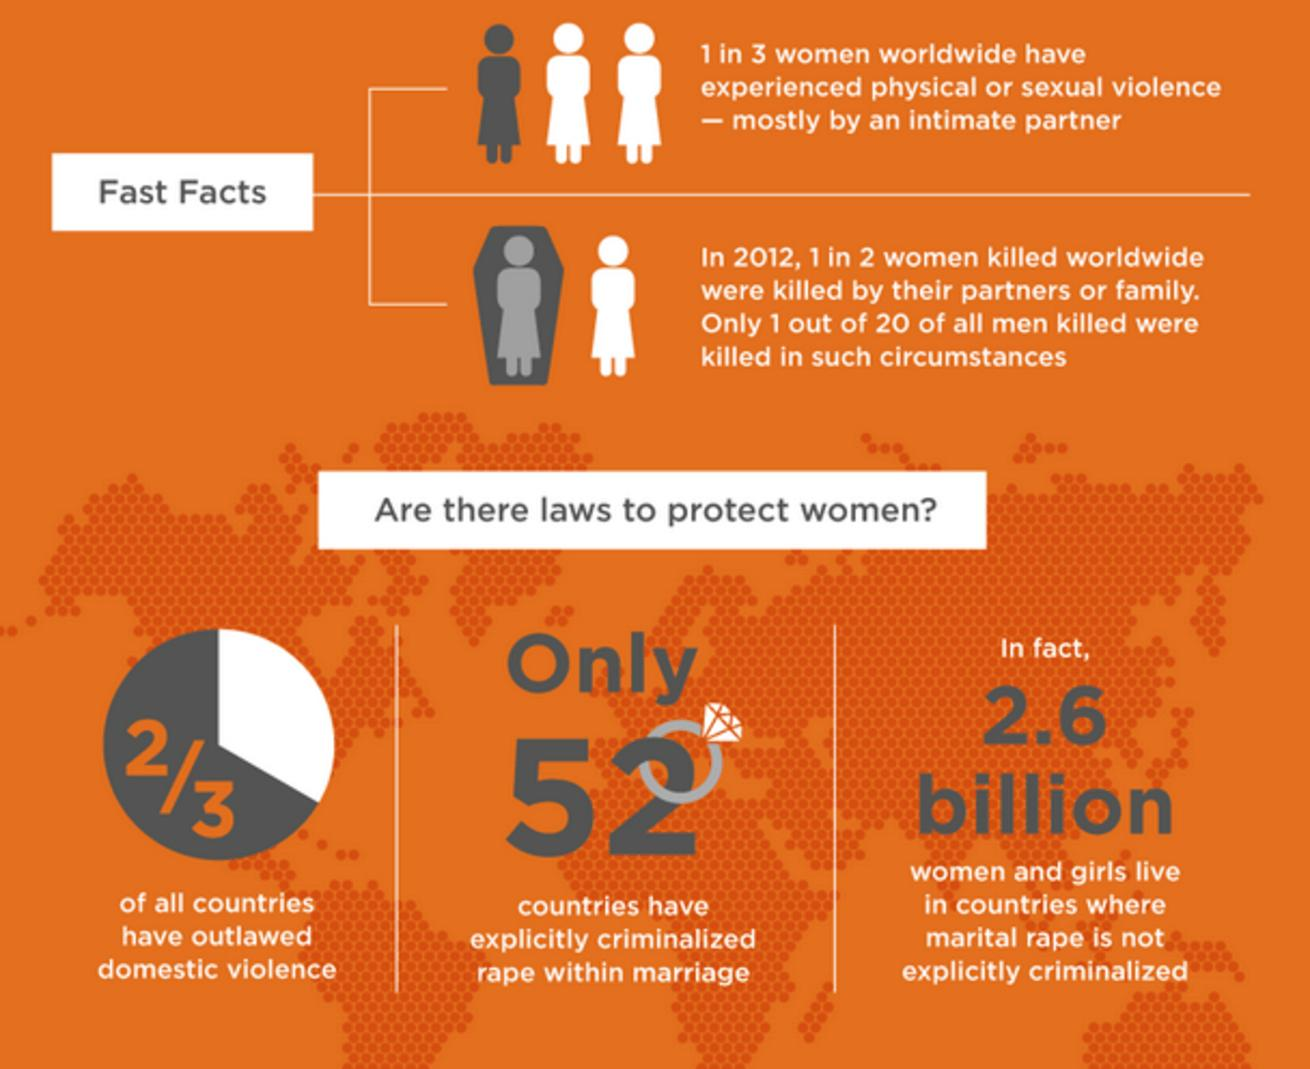Highlight a few significant elements in this photo. As of today, 143 countries have not yet criminalized marital rape. 